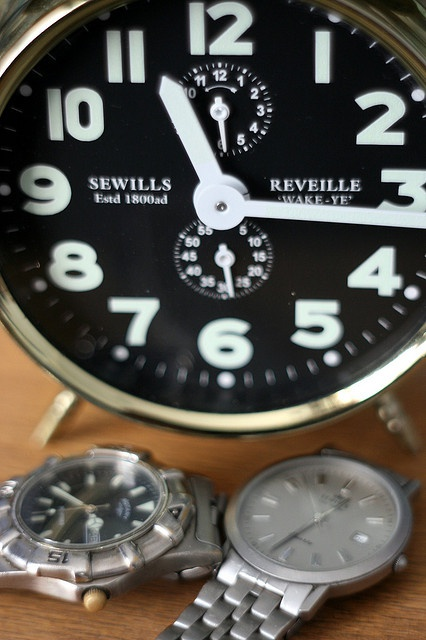Describe the objects in this image and their specific colors. I can see clock in gray, black, lightgray, and darkgray tones, clock in gray tones, and clock in gray, black, darkgray, and purple tones in this image. 